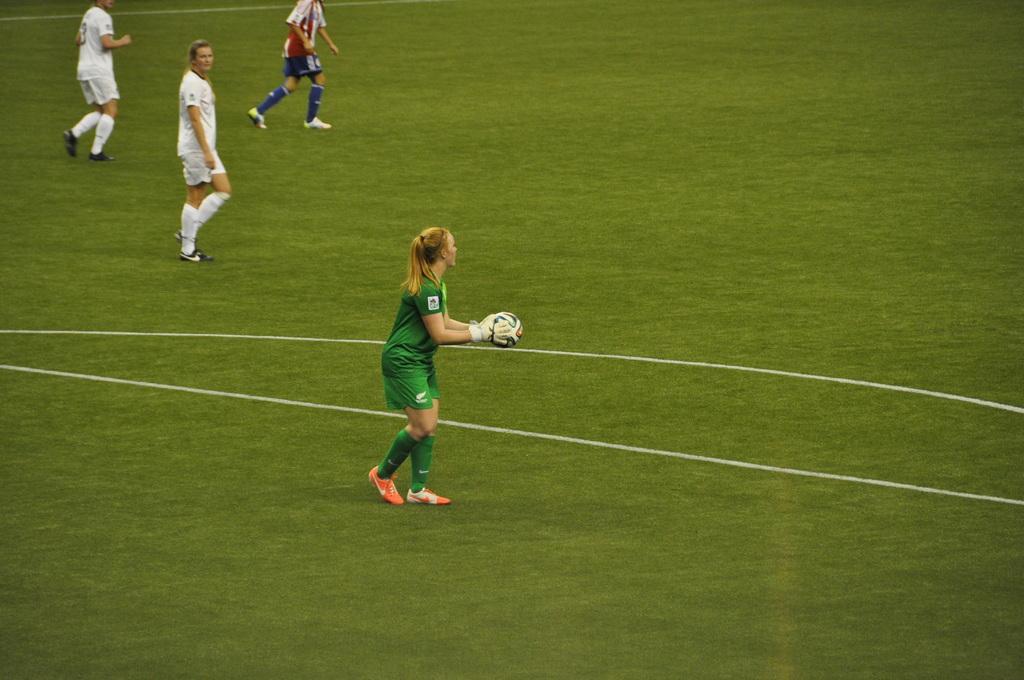Could you give a brief overview of what you see in this image? In this picture there is a woman who is wearing green dress, white gloves and pink color shoes. She is holding a football. In the top left corner I can see three persons who are standing on the football ground. In the bottom I can see the green grass. In the center I can see two white lines. 